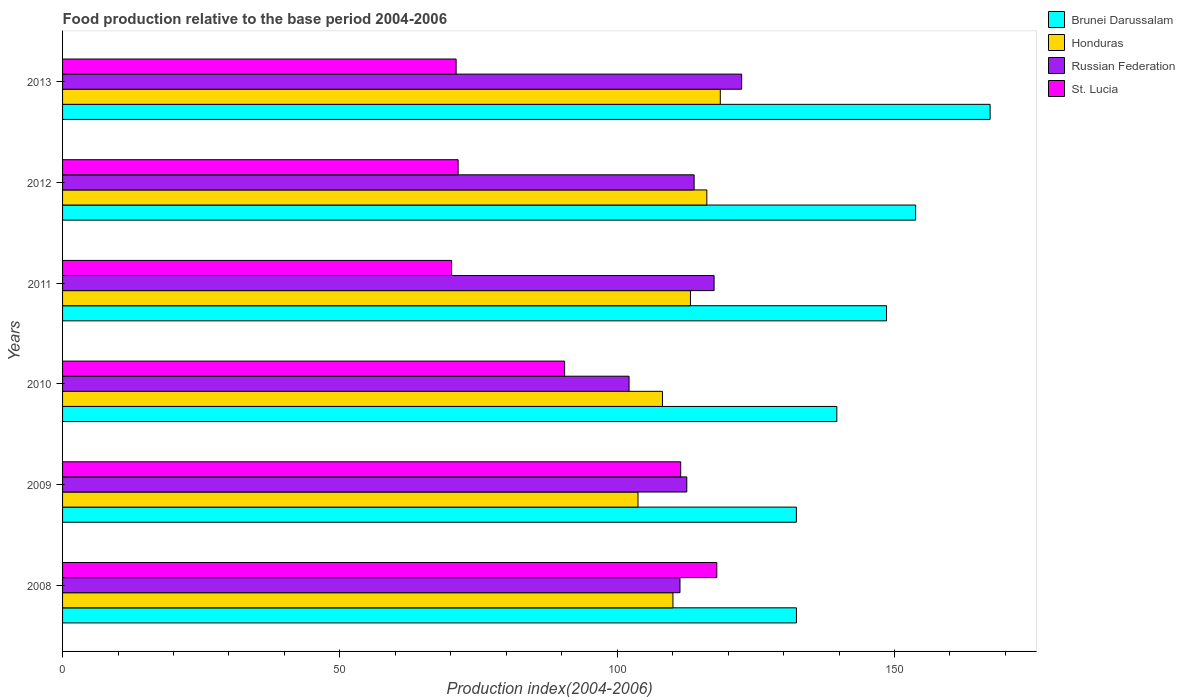How many groups of bars are there?
Your response must be concise. 6. Are the number of bars per tick equal to the number of legend labels?
Keep it short and to the point. Yes. Are the number of bars on each tick of the Y-axis equal?
Provide a succinct answer. Yes. How many bars are there on the 5th tick from the top?
Provide a short and direct response. 4. What is the food production index in Brunei Darussalam in 2012?
Provide a succinct answer. 153.81. Across all years, what is the maximum food production index in Russian Federation?
Your response must be concise. 122.44. Across all years, what is the minimum food production index in Russian Federation?
Keep it short and to the point. 102.14. In which year was the food production index in Honduras maximum?
Your answer should be very brief. 2013. In which year was the food production index in St. Lucia minimum?
Ensure brevity in your answer.  2011. What is the total food production index in Honduras in the graph?
Give a very brief answer. 669.92. What is the difference between the food production index in Brunei Darussalam in 2008 and that in 2013?
Offer a very short reply. -34.92. What is the difference between the food production index in St. Lucia in 2009 and the food production index in Brunei Darussalam in 2011?
Keep it short and to the point. -37.11. What is the average food production index in St. Lucia per year?
Give a very brief answer. 88.73. In the year 2012, what is the difference between the food production index in Honduras and food production index in St. Lucia?
Your response must be concise. 44.84. In how many years, is the food production index in Honduras greater than 100 ?
Ensure brevity in your answer.  6. What is the ratio of the food production index in Brunei Darussalam in 2008 to that in 2009?
Your answer should be compact. 1. What is the difference between the highest and the second highest food production index in St. Lucia?
Provide a short and direct response. 6.51. What is the difference between the highest and the lowest food production index in Honduras?
Your answer should be very brief. 14.84. In how many years, is the food production index in Russian Federation greater than the average food production index in Russian Federation taken over all years?
Ensure brevity in your answer.  3. What does the 3rd bar from the top in 2009 represents?
Give a very brief answer. Honduras. What does the 3rd bar from the bottom in 2011 represents?
Make the answer very short. Russian Federation. Is it the case that in every year, the sum of the food production index in St. Lucia and food production index in Honduras is greater than the food production index in Russian Federation?
Ensure brevity in your answer.  Yes. How many bars are there?
Your response must be concise. 24. What is the difference between two consecutive major ticks on the X-axis?
Your answer should be compact. 50. Does the graph contain any zero values?
Keep it short and to the point. No. Does the graph contain grids?
Make the answer very short. No. Where does the legend appear in the graph?
Keep it short and to the point. Top right. What is the title of the graph?
Provide a short and direct response. Food production relative to the base period 2004-2006. What is the label or title of the X-axis?
Give a very brief answer. Production index(2004-2006). What is the Production index(2004-2006) in Brunei Darussalam in 2008?
Make the answer very short. 132.32. What is the Production index(2004-2006) in Honduras in 2008?
Provide a short and direct response. 110.05. What is the Production index(2004-2006) of Russian Federation in 2008?
Offer a terse response. 111.32. What is the Production index(2004-2006) in St. Lucia in 2008?
Offer a very short reply. 117.96. What is the Production index(2004-2006) of Brunei Darussalam in 2009?
Ensure brevity in your answer.  132.31. What is the Production index(2004-2006) of Honduras in 2009?
Your answer should be compact. 103.75. What is the Production index(2004-2006) of Russian Federation in 2009?
Offer a terse response. 112.55. What is the Production index(2004-2006) of St. Lucia in 2009?
Offer a terse response. 111.45. What is the Production index(2004-2006) of Brunei Darussalam in 2010?
Your response must be concise. 139.6. What is the Production index(2004-2006) in Honduras in 2010?
Your response must be concise. 108.16. What is the Production index(2004-2006) in Russian Federation in 2010?
Ensure brevity in your answer.  102.14. What is the Production index(2004-2006) in St. Lucia in 2010?
Ensure brevity in your answer.  90.52. What is the Production index(2004-2006) in Brunei Darussalam in 2011?
Make the answer very short. 148.56. What is the Production index(2004-2006) in Honduras in 2011?
Make the answer very short. 113.21. What is the Production index(2004-2006) in Russian Federation in 2011?
Keep it short and to the point. 117.47. What is the Production index(2004-2006) of St. Lucia in 2011?
Your answer should be compact. 70.15. What is the Production index(2004-2006) in Brunei Darussalam in 2012?
Provide a succinct answer. 153.81. What is the Production index(2004-2006) in Honduras in 2012?
Provide a succinct answer. 116.16. What is the Production index(2004-2006) of Russian Federation in 2012?
Offer a terse response. 113.87. What is the Production index(2004-2006) of St. Lucia in 2012?
Your answer should be compact. 71.32. What is the Production index(2004-2006) of Brunei Darussalam in 2013?
Make the answer very short. 167.24. What is the Production index(2004-2006) of Honduras in 2013?
Make the answer very short. 118.59. What is the Production index(2004-2006) of Russian Federation in 2013?
Your response must be concise. 122.44. What is the Production index(2004-2006) in St. Lucia in 2013?
Keep it short and to the point. 70.96. Across all years, what is the maximum Production index(2004-2006) in Brunei Darussalam?
Ensure brevity in your answer.  167.24. Across all years, what is the maximum Production index(2004-2006) of Honduras?
Make the answer very short. 118.59. Across all years, what is the maximum Production index(2004-2006) of Russian Federation?
Provide a short and direct response. 122.44. Across all years, what is the maximum Production index(2004-2006) in St. Lucia?
Your response must be concise. 117.96. Across all years, what is the minimum Production index(2004-2006) in Brunei Darussalam?
Give a very brief answer. 132.31. Across all years, what is the minimum Production index(2004-2006) in Honduras?
Provide a succinct answer. 103.75. Across all years, what is the minimum Production index(2004-2006) in Russian Federation?
Offer a very short reply. 102.14. Across all years, what is the minimum Production index(2004-2006) of St. Lucia?
Keep it short and to the point. 70.15. What is the total Production index(2004-2006) of Brunei Darussalam in the graph?
Give a very brief answer. 873.84. What is the total Production index(2004-2006) of Honduras in the graph?
Offer a very short reply. 669.92. What is the total Production index(2004-2006) of Russian Federation in the graph?
Provide a succinct answer. 679.79. What is the total Production index(2004-2006) in St. Lucia in the graph?
Offer a terse response. 532.36. What is the difference between the Production index(2004-2006) in Brunei Darussalam in 2008 and that in 2009?
Offer a very short reply. 0.01. What is the difference between the Production index(2004-2006) in Russian Federation in 2008 and that in 2009?
Your answer should be very brief. -1.23. What is the difference between the Production index(2004-2006) in St. Lucia in 2008 and that in 2009?
Provide a short and direct response. 6.51. What is the difference between the Production index(2004-2006) of Brunei Darussalam in 2008 and that in 2010?
Your answer should be compact. -7.28. What is the difference between the Production index(2004-2006) of Honduras in 2008 and that in 2010?
Give a very brief answer. 1.89. What is the difference between the Production index(2004-2006) in Russian Federation in 2008 and that in 2010?
Make the answer very short. 9.18. What is the difference between the Production index(2004-2006) of St. Lucia in 2008 and that in 2010?
Your response must be concise. 27.44. What is the difference between the Production index(2004-2006) in Brunei Darussalam in 2008 and that in 2011?
Keep it short and to the point. -16.24. What is the difference between the Production index(2004-2006) of Honduras in 2008 and that in 2011?
Make the answer very short. -3.16. What is the difference between the Production index(2004-2006) in Russian Federation in 2008 and that in 2011?
Offer a terse response. -6.15. What is the difference between the Production index(2004-2006) of St. Lucia in 2008 and that in 2011?
Ensure brevity in your answer.  47.81. What is the difference between the Production index(2004-2006) in Brunei Darussalam in 2008 and that in 2012?
Make the answer very short. -21.49. What is the difference between the Production index(2004-2006) in Honduras in 2008 and that in 2012?
Make the answer very short. -6.11. What is the difference between the Production index(2004-2006) of Russian Federation in 2008 and that in 2012?
Make the answer very short. -2.55. What is the difference between the Production index(2004-2006) in St. Lucia in 2008 and that in 2012?
Offer a terse response. 46.64. What is the difference between the Production index(2004-2006) in Brunei Darussalam in 2008 and that in 2013?
Offer a terse response. -34.92. What is the difference between the Production index(2004-2006) in Honduras in 2008 and that in 2013?
Provide a succinct answer. -8.54. What is the difference between the Production index(2004-2006) in Russian Federation in 2008 and that in 2013?
Make the answer very short. -11.12. What is the difference between the Production index(2004-2006) in St. Lucia in 2008 and that in 2013?
Keep it short and to the point. 47. What is the difference between the Production index(2004-2006) in Brunei Darussalam in 2009 and that in 2010?
Provide a short and direct response. -7.29. What is the difference between the Production index(2004-2006) of Honduras in 2009 and that in 2010?
Offer a terse response. -4.41. What is the difference between the Production index(2004-2006) in Russian Federation in 2009 and that in 2010?
Provide a short and direct response. 10.41. What is the difference between the Production index(2004-2006) of St. Lucia in 2009 and that in 2010?
Keep it short and to the point. 20.93. What is the difference between the Production index(2004-2006) in Brunei Darussalam in 2009 and that in 2011?
Offer a terse response. -16.25. What is the difference between the Production index(2004-2006) of Honduras in 2009 and that in 2011?
Give a very brief answer. -9.46. What is the difference between the Production index(2004-2006) in Russian Federation in 2009 and that in 2011?
Offer a terse response. -4.92. What is the difference between the Production index(2004-2006) of St. Lucia in 2009 and that in 2011?
Offer a very short reply. 41.3. What is the difference between the Production index(2004-2006) in Brunei Darussalam in 2009 and that in 2012?
Your response must be concise. -21.5. What is the difference between the Production index(2004-2006) of Honduras in 2009 and that in 2012?
Ensure brevity in your answer.  -12.41. What is the difference between the Production index(2004-2006) of Russian Federation in 2009 and that in 2012?
Ensure brevity in your answer.  -1.32. What is the difference between the Production index(2004-2006) in St. Lucia in 2009 and that in 2012?
Offer a very short reply. 40.13. What is the difference between the Production index(2004-2006) in Brunei Darussalam in 2009 and that in 2013?
Your response must be concise. -34.93. What is the difference between the Production index(2004-2006) of Honduras in 2009 and that in 2013?
Make the answer very short. -14.84. What is the difference between the Production index(2004-2006) of Russian Federation in 2009 and that in 2013?
Your response must be concise. -9.89. What is the difference between the Production index(2004-2006) in St. Lucia in 2009 and that in 2013?
Your response must be concise. 40.49. What is the difference between the Production index(2004-2006) in Brunei Darussalam in 2010 and that in 2011?
Your response must be concise. -8.96. What is the difference between the Production index(2004-2006) of Honduras in 2010 and that in 2011?
Keep it short and to the point. -5.05. What is the difference between the Production index(2004-2006) of Russian Federation in 2010 and that in 2011?
Your response must be concise. -15.33. What is the difference between the Production index(2004-2006) in St. Lucia in 2010 and that in 2011?
Provide a succinct answer. 20.37. What is the difference between the Production index(2004-2006) of Brunei Darussalam in 2010 and that in 2012?
Your answer should be compact. -14.21. What is the difference between the Production index(2004-2006) of Russian Federation in 2010 and that in 2012?
Keep it short and to the point. -11.73. What is the difference between the Production index(2004-2006) in St. Lucia in 2010 and that in 2012?
Provide a succinct answer. 19.2. What is the difference between the Production index(2004-2006) of Brunei Darussalam in 2010 and that in 2013?
Your answer should be compact. -27.64. What is the difference between the Production index(2004-2006) of Honduras in 2010 and that in 2013?
Your answer should be very brief. -10.43. What is the difference between the Production index(2004-2006) in Russian Federation in 2010 and that in 2013?
Your answer should be compact. -20.3. What is the difference between the Production index(2004-2006) of St. Lucia in 2010 and that in 2013?
Offer a very short reply. 19.56. What is the difference between the Production index(2004-2006) of Brunei Darussalam in 2011 and that in 2012?
Offer a terse response. -5.25. What is the difference between the Production index(2004-2006) in Honduras in 2011 and that in 2012?
Ensure brevity in your answer.  -2.95. What is the difference between the Production index(2004-2006) of Russian Federation in 2011 and that in 2012?
Offer a terse response. 3.6. What is the difference between the Production index(2004-2006) in St. Lucia in 2011 and that in 2012?
Offer a very short reply. -1.17. What is the difference between the Production index(2004-2006) of Brunei Darussalam in 2011 and that in 2013?
Your answer should be very brief. -18.68. What is the difference between the Production index(2004-2006) in Honduras in 2011 and that in 2013?
Keep it short and to the point. -5.38. What is the difference between the Production index(2004-2006) in Russian Federation in 2011 and that in 2013?
Provide a succinct answer. -4.97. What is the difference between the Production index(2004-2006) in St. Lucia in 2011 and that in 2013?
Provide a short and direct response. -0.81. What is the difference between the Production index(2004-2006) in Brunei Darussalam in 2012 and that in 2013?
Ensure brevity in your answer.  -13.43. What is the difference between the Production index(2004-2006) in Honduras in 2012 and that in 2013?
Provide a short and direct response. -2.43. What is the difference between the Production index(2004-2006) of Russian Federation in 2012 and that in 2013?
Make the answer very short. -8.57. What is the difference between the Production index(2004-2006) of St. Lucia in 2012 and that in 2013?
Offer a very short reply. 0.36. What is the difference between the Production index(2004-2006) of Brunei Darussalam in 2008 and the Production index(2004-2006) of Honduras in 2009?
Make the answer very short. 28.57. What is the difference between the Production index(2004-2006) in Brunei Darussalam in 2008 and the Production index(2004-2006) in Russian Federation in 2009?
Offer a terse response. 19.77. What is the difference between the Production index(2004-2006) of Brunei Darussalam in 2008 and the Production index(2004-2006) of St. Lucia in 2009?
Keep it short and to the point. 20.87. What is the difference between the Production index(2004-2006) of Honduras in 2008 and the Production index(2004-2006) of Russian Federation in 2009?
Your answer should be compact. -2.5. What is the difference between the Production index(2004-2006) in Russian Federation in 2008 and the Production index(2004-2006) in St. Lucia in 2009?
Give a very brief answer. -0.13. What is the difference between the Production index(2004-2006) of Brunei Darussalam in 2008 and the Production index(2004-2006) of Honduras in 2010?
Offer a very short reply. 24.16. What is the difference between the Production index(2004-2006) of Brunei Darussalam in 2008 and the Production index(2004-2006) of Russian Federation in 2010?
Your answer should be very brief. 30.18. What is the difference between the Production index(2004-2006) of Brunei Darussalam in 2008 and the Production index(2004-2006) of St. Lucia in 2010?
Your answer should be very brief. 41.8. What is the difference between the Production index(2004-2006) of Honduras in 2008 and the Production index(2004-2006) of Russian Federation in 2010?
Provide a short and direct response. 7.91. What is the difference between the Production index(2004-2006) in Honduras in 2008 and the Production index(2004-2006) in St. Lucia in 2010?
Give a very brief answer. 19.53. What is the difference between the Production index(2004-2006) of Russian Federation in 2008 and the Production index(2004-2006) of St. Lucia in 2010?
Make the answer very short. 20.8. What is the difference between the Production index(2004-2006) in Brunei Darussalam in 2008 and the Production index(2004-2006) in Honduras in 2011?
Your answer should be compact. 19.11. What is the difference between the Production index(2004-2006) in Brunei Darussalam in 2008 and the Production index(2004-2006) in Russian Federation in 2011?
Your answer should be compact. 14.85. What is the difference between the Production index(2004-2006) of Brunei Darussalam in 2008 and the Production index(2004-2006) of St. Lucia in 2011?
Make the answer very short. 62.17. What is the difference between the Production index(2004-2006) in Honduras in 2008 and the Production index(2004-2006) in Russian Federation in 2011?
Your answer should be compact. -7.42. What is the difference between the Production index(2004-2006) of Honduras in 2008 and the Production index(2004-2006) of St. Lucia in 2011?
Keep it short and to the point. 39.9. What is the difference between the Production index(2004-2006) of Russian Federation in 2008 and the Production index(2004-2006) of St. Lucia in 2011?
Offer a terse response. 41.17. What is the difference between the Production index(2004-2006) of Brunei Darussalam in 2008 and the Production index(2004-2006) of Honduras in 2012?
Your answer should be very brief. 16.16. What is the difference between the Production index(2004-2006) in Brunei Darussalam in 2008 and the Production index(2004-2006) in Russian Federation in 2012?
Give a very brief answer. 18.45. What is the difference between the Production index(2004-2006) of Brunei Darussalam in 2008 and the Production index(2004-2006) of St. Lucia in 2012?
Offer a very short reply. 61. What is the difference between the Production index(2004-2006) of Honduras in 2008 and the Production index(2004-2006) of Russian Federation in 2012?
Provide a short and direct response. -3.82. What is the difference between the Production index(2004-2006) of Honduras in 2008 and the Production index(2004-2006) of St. Lucia in 2012?
Offer a very short reply. 38.73. What is the difference between the Production index(2004-2006) of Brunei Darussalam in 2008 and the Production index(2004-2006) of Honduras in 2013?
Give a very brief answer. 13.73. What is the difference between the Production index(2004-2006) of Brunei Darussalam in 2008 and the Production index(2004-2006) of Russian Federation in 2013?
Provide a succinct answer. 9.88. What is the difference between the Production index(2004-2006) in Brunei Darussalam in 2008 and the Production index(2004-2006) in St. Lucia in 2013?
Your response must be concise. 61.36. What is the difference between the Production index(2004-2006) of Honduras in 2008 and the Production index(2004-2006) of Russian Federation in 2013?
Provide a short and direct response. -12.39. What is the difference between the Production index(2004-2006) in Honduras in 2008 and the Production index(2004-2006) in St. Lucia in 2013?
Give a very brief answer. 39.09. What is the difference between the Production index(2004-2006) in Russian Federation in 2008 and the Production index(2004-2006) in St. Lucia in 2013?
Your answer should be compact. 40.36. What is the difference between the Production index(2004-2006) of Brunei Darussalam in 2009 and the Production index(2004-2006) of Honduras in 2010?
Ensure brevity in your answer.  24.15. What is the difference between the Production index(2004-2006) in Brunei Darussalam in 2009 and the Production index(2004-2006) in Russian Federation in 2010?
Offer a terse response. 30.17. What is the difference between the Production index(2004-2006) in Brunei Darussalam in 2009 and the Production index(2004-2006) in St. Lucia in 2010?
Your answer should be compact. 41.79. What is the difference between the Production index(2004-2006) in Honduras in 2009 and the Production index(2004-2006) in Russian Federation in 2010?
Provide a succinct answer. 1.61. What is the difference between the Production index(2004-2006) of Honduras in 2009 and the Production index(2004-2006) of St. Lucia in 2010?
Offer a terse response. 13.23. What is the difference between the Production index(2004-2006) in Russian Federation in 2009 and the Production index(2004-2006) in St. Lucia in 2010?
Provide a succinct answer. 22.03. What is the difference between the Production index(2004-2006) of Brunei Darussalam in 2009 and the Production index(2004-2006) of Honduras in 2011?
Ensure brevity in your answer.  19.1. What is the difference between the Production index(2004-2006) of Brunei Darussalam in 2009 and the Production index(2004-2006) of Russian Federation in 2011?
Keep it short and to the point. 14.84. What is the difference between the Production index(2004-2006) of Brunei Darussalam in 2009 and the Production index(2004-2006) of St. Lucia in 2011?
Your answer should be very brief. 62.16. What is the difference between the Production index(2004-2006) in Honduras in 2009 and the Production index(2004-2006) in Russian Federation in 2011?
Your answer should be compact. -13.72. What is the difference between the Production index(2004-2006) of Honduras in 2009 and the Production index(2004-2006) of St. Lucia in 2011?
Keep it short and to the point. 33.6. What is the difference between the Production index(2004-2006) in Russian Federation in 2009 and the Production index(2004-2006) in St. Lucia in 2011?
Provide a succinct answer. 42.4. What is the difference between the Production index(2004-2006) in Brunei Darussalam in 2009 and the Production index(2004-2006) in Honduras in 2012?
Give a very brief answer. 16.15. What is the difference between the Production index(2004-2006) in Brunei Darussalam in 2009 and the Production index(2004-2006) in Russian Federation in 2012?
Your answer should be very brief. 18.44. What is the difference between the Production index(2004-2006) in Brunei Darussalam in 2009 and the Production index(2004-2006) in St. Lucia in 2012?
Ensure brevity in your answer.  60.99. What is the difference between the Production index(2004-2006) of Honduras in 2009 and the Production index(2004-2006) of Russian Federation in 2012?
Offer a terse response. -10.12. What is the difference between the Production index(2004-2006) in Honduras in 2009 and the Production index(2004-2006) in St. Lucia in 2012?
Your response must be concise. 32.43. What is the difference between the Production index(2004-2006) in Russian Federation in 2009 and the Production index(2004-2006) in St. Lucia in 2012?
Provide a succinct answer. 41.23. What is the difference between the Production index(2004-2006) of Brunei Darussalam in 2009 and the Production index(2004-2006) of Honduras in 2013?
Offer a very short reply. 13.72. What is the difference between the Production index(2004-2006) of Brunei Darussalam in 2009 and the Production index(2004-2006) of Russian Federation in 2013?
Keep it short and to the point. 9.87. What is the difference between the Production index(2004-2006) of Brunei Darussalam in 2009 and the Production index(2004-2006) of St. Lucia in 2013?
Your answer should be very brief. 61.35. What is the difference between the Production index(2004-2006) of Honduras in 2009 and the Production index(2004-2006) of Russian Federation in 2013?
Your response must be concise. -18.69. What is the difference between the Production index(2004-2006) of Honduras in 2009 and the Production index(2004-2006) of St. Lucia in 2013?
Your answer should be very brief. 32.79. What is the difference between the Production index(2004-2006) in Russian Federation in 2009 and the Production index(2004-2006) in St. Lucia in 2013?
Your response must be concise. 41.59. What is the difference between the Production index(2004-2006) in Brunei Darussalam in 2010 and the Production index(2004-2006) in Honduras in 2011?
Keep it short and to the point. 26.39. What is the difference between the Production index(2004-2006) in Brunei Darussalam in 2010 and the Production index(2004-2006) in Russian Federation in 2011?
Keep it short and to the point. 22.13. What is the difference between the Production index(2004-2006) in Brunei Darussalam in 2010 and the Production index(2004-2006) in St. Lucia in 2011?
Provide a short and direct response. 69.45. What is the difference between the Production index(2004-2006) in Honduras in 2010 and the Production index(2004-2006) in Russian Federation in 2011?
Offer a terse response. -9.31. What is the difference between the Production index(2004-2006) of Honduras in 2010 and the Production index(2004-2006) of St. Lucia in 2011?
Keep it short and to the point. 38.01. What is the difference between the Production index(2004-2006) of Russian Federation in 2010 and the Production index(2004-2006) of St. Lucia in 2011?
Your response must be concise. 31.99. What is the difference between the Production index(2004-2006) in Brunei Darussalam in 2010 and the Production index(2004-2006) in Honduras in 2012?
Make the answer very short. 23.44. What is the difference between the Production index(2004-2006) in Brunei Darussalam in 2010 and the Production index(2004-2006) in Russian Federation in 2012?
Ensure brevity in your answer.  25.73. What is the difference between the Production index(2004-2006) in Brunei Darussalam in 2010 and the Production index(2004-2006) in St. Lucia in 2012?
Provide a short and direct response. 68.28. What is the difference between the Production index(2004-2006) of Honduras in 2010 and the Production index(2004-2006) of Russian Federation in 2012?
Make the answer very short. -5.71. What is the difference between the Production index(2004-2006) of Honduras in 2010 and the Production index(2004-2006) of St. Lucia in 2012?
Make the answer very short. 36.84. What is the difference between the Production index(2004-2006) in Russian Federation in 2010 and the Production index(2004-2006) in St. Lucia in 2012?
Provide a succinct answer. 30.82. What is the difference between the Production index(2004-2006) in Brunei Darussalam in 2010 and the Production index(2004-2006) in Honduras in 2013?
Keep it short and to the point. 21.01. What is the difference between the Production index(2004-2006) of Brunei Darussalam in 2010 and the Production index(2004-2006) of Russian Federation in 2013?
Your answer should be compact. 17.16. What is the difference between the Production index(2004-2006) of Brunei Darussalam in 2010 and the Production index(2004-2006) of St. Lucia in 2013?
Make the answer very short. 68.64. What is the difference between the Production index(2004-2006) in Honduras in 2010 and the Production index(2004-2006) in Russian Federation in 2013?
Your answer should be very brief. -14.28. What is the difference between the Production index(2004-2006) of Honduras in 2010 and the Production index(2004-2006) of St. Lucia in 2013?
Ensure brevity in your answer.  37.2. What is the difference between the Production index(2004-2006) of Russian Federation in 2010 and the Production index(2004-2006) of St. Lucia in 2013?
Provide a short and direct response. 31.18. What is the difference between the Production index(2004-2006) in Brunei Darussalam in 2011 and the Production index(2004-2006) in Honduras in 2012?
Keep it short and to the point. 32.4. What is the difference between the Production index(2004-2006) of Brunei Darussalam in 2011 and the Production index(2004-2006) of Russian Federation in 2012?
Make the answer very short. 34.69. What is the difference between the Production index(2004-2006) of Brunei Darussalam in 2011 and the Production index(2004-2006) of St. Lucia in 2012?
Keep it short and to the point. 77.24. What is the difference between the Production index(2004-2006) in Honduras in 2011 and the Production index(2004-2006) in Russian Federation in 2012?
Keep it short and to the point. -0.66. What is the difference between the Production index(2004-2006) of Honduras in 2011 and the Production index(2004-2006) of St. Lucia in 2012?
Provide a succinct answer. 41.89. What is the difference between the Production index(2004-2006) of Russian Federation in 2011 and the Production index(2004-2006) of St. Lucia in 2012?
Ensure brevity in your answer.  46.15. What is the difference between the Production index(2004-2006) in Brunei Darussalam in 2011 and the Production index(2004-2006) in Honduras in 2013?
Provide a short and direct response. 29.97. What is the difference between the Production index(2004-2006) of Brunei Darussalam in 2011 and the Production index(2004-2006) of Russian Federation in 2013?
Make the answer very short. 26.12. What is the difference between the Production index(2004-2006) in Brunei Darussalam in 2011 and the Production index(2004-2006) in St. Lucia in 2013?
Your answer should be compact. 77.6. What is the difference between the Production index(2004-2006) of Honduras in 2011 and the Production index(2004-2006) of Russian Federation in 2013?
Provide a short and direct response. -9.23. What is the difference between the Production index(2004-2006) of Honduras in 2011 and the Production index(2004-2006) of St. Lucia in 2013?
Make the answer very short. 42.25. What is the difference between the Production index(2004-2006) in Russian Federation in 2011 and the Production index(2004-2006) in St. Lucia in 2013?
Provide a succinct answer. 46.51. What is the difference between the Production index(2004-2006) in Brunei Darussalam in 2012 and the Production index(2004-2006) in Honduras in 2013?
Ensure brevity in your answer.  35.22. What is the difference between the Production index(2004-2006) of Brunei Darussalam in 2012 and the Production index(2004-2006) of Russian Federation in 2013?
Your answer should be compact. 31.37. What is the difference between the Production index(2004-2006) of Brunei Darussalam in 2012 and the Production index(2004-2006) of St. Lucia in 2013?
Give a very brief answer. 82.85. What is the difference between the Production index(2004-2006) in Honduras in 2012 and the Production index(2004-2006) in Russian Federation in 2013?
Your answer should be very brief. -6.28. What is the difference between the Production index(2004-2006) of Honduras in 2012 and the Production index(2004-2006) of St. Lucia in 2013?
Make the answer very short. 45.2. What is the difference between the Production index(2004-2006) of Russian Federation in 2012 and the Production index(2004-2006) of St. Lucia in 2013?
Provide a succinct answer. 42.91. What is the average Production index(2004-2006) in Brunei Darussalam per year?
Offer a very short reply. 145.64. What is the average Production index(2004-2006) in Honduras per year?
Your answer should be compact. 111.65. What is the average Production index(2004-2006) in Russian Federation per year?
Provide a succinct answer. 113.3. What is the average Production index(2004-2006) in St. Lucia per year?
Provide a short and direct response. 88.73. In the year 2008, what is the difference between the Production index(2004-2006) of Brunei Darussalam and Production index(2004-2006) of Honduras?
Make the answer very short. 22.27. In the year 2008, what is the difference between the Production index(2004-2006) in Brunei Darussalam and Production index(2004-2006) in Russian Federation?
Offer a terse response. 21. In the year 2008, what is the difference between the Production index(2004-2006) in Brunei Darussalam and Production index(2004-2006) in St. Lucia?
Ensure brevity in your answer.  14.36. In the year 2008, what is the difference between the Production index(2004-2006) in Honduras and Production index(2004-2006) in Russian Federation?
Your answer should be very brief. -1.27. In the year 2008, what is the difference between the Production index(2004-2006) of Honduras and Production index(2004-2006) of St. Lucia?
Your answer should be very brief. -7.91. In the year 2008, what is the difference between the Production index(2004-2006) in Russian Federation and Production index(2004-2006) in St. Lucia?
Provide a short and direct response. -6.64. In the year 2009, what is the difference between the Production index(2004-2006) of Brunei Darussalam and Production index(2004-2006) of Honduras?
Your answer should be compact. 28.56. In the year 2009, what is the difference between the Production index(2004-2006) in Brunei Darussalam and Production index(2004-2006) in Russian Federation?
Your response must be concise. 19.76. In the year 2009, what is the difference between the Production index(2004-2006) in Brunei Darussalam and Production index(2004-2006) in St. Lucia?
Make the answer very short. 20.86. In the year 2009, what is the difference between the Production index(2004-2006) in Russian Federation and Production index(2004-2006) in St. Lucia?
Make the answer very short. 1.1. In the year 2010, what is the difference between the Production index(2004-2006) in Brunei Darussalam and Production index(2004-2006) in Honduras?
Offer a very short reply. 31.44. In the year 2010, what is the difference between the Production index(2004-2006) in Brunei Darussalam and Production index(2004-2006) in Russian Federation?
Offer a terse response. 37.46. In the year 2010, what is the difference between the Production index(2004-2006) in Brunei Darussalam and Production index(2004-2006) in St. Lucia?
Offer a very short reply. 49.08. In the year 2010, what is the difference between the Production index(2004-2006) of Honduras and Production index(2004-2006) of Russian Federation?
Provide a succinct answer. 6.02. In the year 2010, what is the difference between the Production index(2004-2006) of Honduras and Production index(2004-2006) of St. Lucia?
Ensure brevity in your answer.  17.64. In the year 2010, what is the difference between the Production index(2004-2006) of Russian Federation and Production index(2004-2006) of St. Lucia?
Your answer should be very brief. 11.62. In the year 2011, what is the difference between the Production index(2004-2006) in Brunei Darussalam and Production index(2004-2006) in Honduras?
Provide a short and direct response. 35.35. In the year 2011, what is the difference between the Production index(2004-2006) in Brunei Darussalam and Production index(2004-2006) in Russian Federation?
Your answer should be compact. 31.09. In the year 2011, what is the difference between the Production index(2004-2006) in Brunei Darussalam and Production index(2004-2006) in St. Lucia?
Offer a very short reply. 78.41. In the year 2011, what is the difference between the Production index(2004-2006) of Honduras and Production index(2004-2006) of Russian Federation?
Ensure brevity in your answer.  -4.26. In the year 2011, what is the difference between the Production index(2004-2006) of Honduras and Production index(2004-2006) of St. Lucia?
Provide a succinct answer. 43.06. In the year 2011, what is the difference between the Production index(2004-2006) in Russian Federation and Production index(2004-2006) in St. Lucia?
Your answer should be compact. 47.32. In the year 2012, what is the difference between the Production index(2004-2006) in Brunei Darussalam and Production index(2004-2006) in Honduras?
Give a very brief answer. 37.65. In the year 2012, what is the difference between the Production index(2004-2006) in Brunei Darussalam and Production index(2004-2006) in Russian Federation?
Provide a short and direct response. 39.94. In the year 2012, what is the difference between the Production index(2004-2006) of Brunei Darussalam and Production index(2004-2006) of St. Lucia?
Your answer should be compact. 82.49. In the year 2012, what is the difference between the Production index(2004-2006) of Honduras and Production index(2004-2006) of Russian Federation?
Offer a terse response. 2.29. In the year 2012, what is the difference between the Production index(2004-2006) in Honduras and Production index(2004-2006) in St. Lucia?
Offer a very short reply. 44.84. In the year 2012, what is the difference between the Production index(2004-2006) of Russian Federation and Production index(2004-2006) of St. Lucia?
Make the answer very short. 42.55. In the year 2013, what is the difference between the Production index(2004-2006) of Brunei Darussalam and Production index(2004-2006) of Honduras?
Make the answer very short. 48.65. In the year 2013, what is the difference between the Production index(2004-2006) of Brunei Darussalam and Production index(2004-2006) of Russian Federation?
Provide a short and direct response. 44.8. In the year 2013, what is the difference between the Production index(2004-2006) of Brunei Darussalam and Production index(2004-2006) of St. Lucia?
Your answer should be compact. 96.28. In the year 2013, what is the difference between the Production index(2004-2006) in Honduras and Production index(2004-2006) in Russian Federation?
Your response must be concise. -3.85. In the year 2013, what is the difference between the Production index(2004-2006) of Honduras and Production index(2004-2006) of St. Lucia?
Provide a succinct answer. 47.63. In the year 2013, what is the difference between the Production index(2004-2006) in Russian Federation and Production index(2004-2006) in St. Lucia?
Offer a very short reply. 51.48. What is the ratio of the Production index(2004-2006) in Brunei Darussalam in 2008 to that in 2009?
Make the answer very short. 1. What is the ratio of the Production index(2004-2006) of Honduras in 2008 to that in 2009?
Your answer should be compact. 1.06. What is the ratio of the Production index(2004-2006) in Russian Federation in 2008 to that in 2009?
Provide a succinct answer. 0.99. What is the ratio of the Production index(2004-2006) of St. Lucia in 2008 to that in 2009?
Provide a succinct answer. 1.06. What is the ratio of the Production index(2004-2006) of Brunei Darussalam in 2008 to that in 2010?
Offer a terse response. 0.95. What is the ratio of the Production index(2004-2006) in Honduras in 2008 to that in 2010?
Offer a very short reply. 1.02. What is the ratio of the Production index(2004-2006) of Russian Federation in 2008 to that in 2010?
Your answer should be compact. 1.09. What is the ratio of the Production index(2004-2006) in St. Lucia in 2008 to that in 2010?
Offer a terse response. 1.3. What is the ratio of the Production index(2004-2006) in Brunei Darussalam in 2008 to that in 2011?
Make the answer very short. 0.89. What is the ratio of the Production index(2004-2006) in Honduras in 2008 to that in 2011?
Your answer should be very brief. 0.97. What is the ratio of the Production index(2004-2006) of Russian Federation in 2008 to that in 2011?
Offer a terse response. 0.95. What is the ratio of the Production index(2004-2006) of St. Lucia in 2008 to that in 2011?
Your answer should be very brief. 1.68. What is the ratio of the Production index(2004-2006) of Brunei Darussalam in 2008 to that in 2012?
Ensure brevity in your answer.  0.86. What is the ratio of the Production index(2004-2006) of Honduras in 2008 to that in 2012?
Give a very brief answer. 0.95. What is the ratio of the Production index(2004-2006) of Russian Federation in 2008 to that in 2012?
Make the answer very short. 0.98. What is the ratio of the Production index(2004-2006) of St. Lucia in 2008 to that in 2012?
Offer a very short reply. 1.65. What is the ratio of the Production index(2004-2006) of Brunei Darussalam in 2008 to that in 2013?
Your answer should be very brief. 0.79. What is the ratio of the Production index(2004-2006) of Honduras in 2008 to that in 2013?
Keep it short and to the point. 0.93. What is the ratio of the Production index(2004-2006) in Russian Federation in 2008 to that in 2013?
Your answer should be compact. 0.91. What is the ratio of the Production index(2004-2006) in St. Lucia in 2008 to that in 2013?
Give a very brief answer. 1.66. What is the ratio of the Production index(2004-2006) of Brunei Darussalam in 2009 to that in 2010?
Give a very brief answer. 0.95. What is the ratio of the Production index(2004-2006) in Honduras in 2009 to that in 2010?
Provide a short and direct response. 0.96. What is the ratio of the Production index(2004-2006) in Russian Federation in 2009 to that in 2010?
Provide a short and direct response. 1.1. What is the ratio of the Production index(2004-2006) in St. Lucia in 2009 to that in 2010?
Your response must be concise. 1.23. What is the ratio of the Production index(2004-2006) of Brunei Darussalam in 2009 to that in 2011?
Keep it short and to the point. 0.89. What is the ratio of the Production index(2004-2006) of Honduras in 2009 to that in 2011?
Your response must be concise. 0.92. What is the ratio of the Production index(2004-2006) of Russian Federation in 2009 to that in 2011?
Keep it short and to the point. 0.96. What is the ratio of the Production index(2004-2006) of St. Lucia in 2009 to that in 2011?
Ensure brevity in your answer.  1.59. What is the ratio of the Production index(2004-2006) of Brunei Darussalam in 2009 to that in 2012?
Offer a terse response. 0.86. What is the ratio of the Production index(2004-2006) in Honduras in 2009 to that in 2012?
Provide a succinct answer. 0.89. What is the ratio of the Production index(2004-2006) in Russian Federation in 2009 to that in 2012?
Offer a very short reply. 0.99. What is the ratio of the Production index(2004-2006) of St. Lucia in 2009 to that in 2012?
Offer a very short reply. 1.56. What is the ratio of the Production index(2004-2006) in Brunei Darussalam in 2009 to that in 2013?
Your response must be concise. 0.79. What is the ratio of the Production index(2004-2006) of Honduras in 2009 to that in 2013?
Give a very brief answer. 0.87. What is the ratio of the Production index(2004-2006) of Russian Federation in 2009 to that in 2013?
Your response must be concise. 0.92. What is the ratio of the Production index(2004-2006) in St. Lucia in 2009 to that in 2013?
Offer a very short reply. 1.57. What is the ratio of the Production index(2004-2006) in Brunei Darussalam in 2010 to that in 2011?
Provide a succinct answer. 0.94. What is the ratio of the Production index(2004-2006) of Honduras in 2010 to that in 2011?
Your response must be concise. 0.96. What is the ratio of the Production index(2004-2006) in Russian Federation in 2010 to that in 2011?
Provide a short and direct response. 0.87. What is the ratio of the Production index(2004-2006) of St. Lucia in 2010 to that in 2011?
Offer a terse response. 1.29. What is the ratio of the Production index(2004-2006) in Brunei Darussalam in 2010 to that in 2012?
Give a very brief answer. 0.91. What is the ratio of the Production index(2004-2006) in Honduras in 2010 to that in 2012?
Give a very brief answer. 0.93. What is the ratio of the Production index(2004-2006) of Russian Federation in 2010 to that in 2012?
Ensure brevity in your answer.  0.9. What is the ratio of the Production index(2004-2006) of St. Lucia in 2010 to that in 2012?
Your response must be concise. 1.27. What is the ratio of the Production index(2004-2006) in Brunei Darussalam in 2010 to that in 2013?
Offer a very short reply. 0.83. What is the ratio of the Production index(2004-2006) of Honduras in 2010 to that in 2013?
Offer a terse response. 0.91. What is the ratio of the Production index(2004-2006) in Russian Federation in 2010 to that in 2013?
Ensure brevity in your answer.  0.83. What is the ratio of the Production index(2004-2006) of St. Lucia in 2010 to that in 2013?
Ensure brevity in your answer.  1.28. What is the ratio of the Production index(2004-2006) of Brunei Darussalam in 2011 to that in 2012?
Your answer should be very brief. 0.97. What is the ratio of the Production index(2004-2006) in Honduras in 2011 to that in 2012?
Offer a terse response. 0.97. What is the ratio of the Production index(2004-2006) of Russian Federation in 2011 to that in 2012?
Make the answer very short. 1.03. What is the ratio of the Production index(2004-2006) in St. Lucia in 2011 to that in 2012?
Offer a very short reply. 0.98. What is the ratio of the Production index(2004-2006) in Brunei Darussalam in 2011 to that in 2013?
Your answer should be very brief. 0.89. What is the ratio of the Production index(2004-2006) of Honduras in 2011 to that in 2013?
Give a very brief answer. 0.95. What is the ratio of the Production index(2004-2006) of Russian Federation in 2011 to that in 2013?
Offer a very short reply. 0.96. What is the ratio of the Production index(2004-2006) of Brunei Darussalam in 2012 to that in 2013?
Offer a very short reply. 0.92. What is the ratio of the Production index(2004-2006) of Honduras in 2012 to that in 2013?
Your response must be concise. 0.98. What is the ratio of the Production index(2004-2006) in Russian Federation in 2012 to that in 2013?
Offer a terse response. 0.93. What is the difference between the highest and the second highest Production index(2004-2006) in Brunei Darussalam?
Provide a succinct answer. 13.43. What is the difference between the highest and the second highest Production index(2004-2006) of Honduras?
Offer a terse response. 2.43. What is the difference between the highest and the second highest Production index(2004-2006) of Russian Federation?
Offer a terse response. 4.97. What is the difference between the highest and the second highest Production index(2004-2006) of St. Lucia?
Make the answer very short. 6.51. What is the difference between the highest and the lowest Production index(2004-2006) in Brunei Darussalam?
Keep it short and to the point. 34.93. What is the difference between the highest and the lowest Production index(2004-2006) in Honduras?
Your response must be concise. 14.84. What is the difference between the highest and the lowest Production index(2004-2006) in Russian Federation?
Your response must be concise. 20.3. What is the difference between the highest and the lowest Production index(2004-2006) in St. Lucia?
Provide a succinct answer. 47.81. 